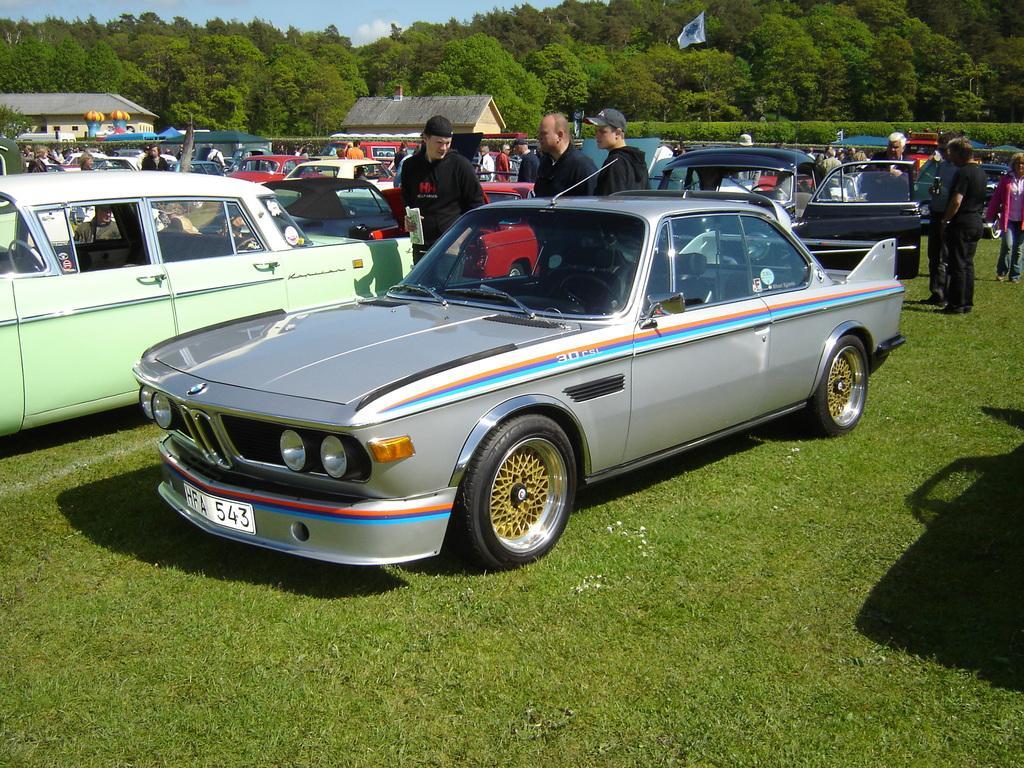In one or two sentences, can you explain what this image depicts? In this image we can see some cars which are parked on the ground. We can also see some people standing beside them. On the backside we can see some houses with roof, plants, a group of trees, the flag and the sky which looks cloudy. 